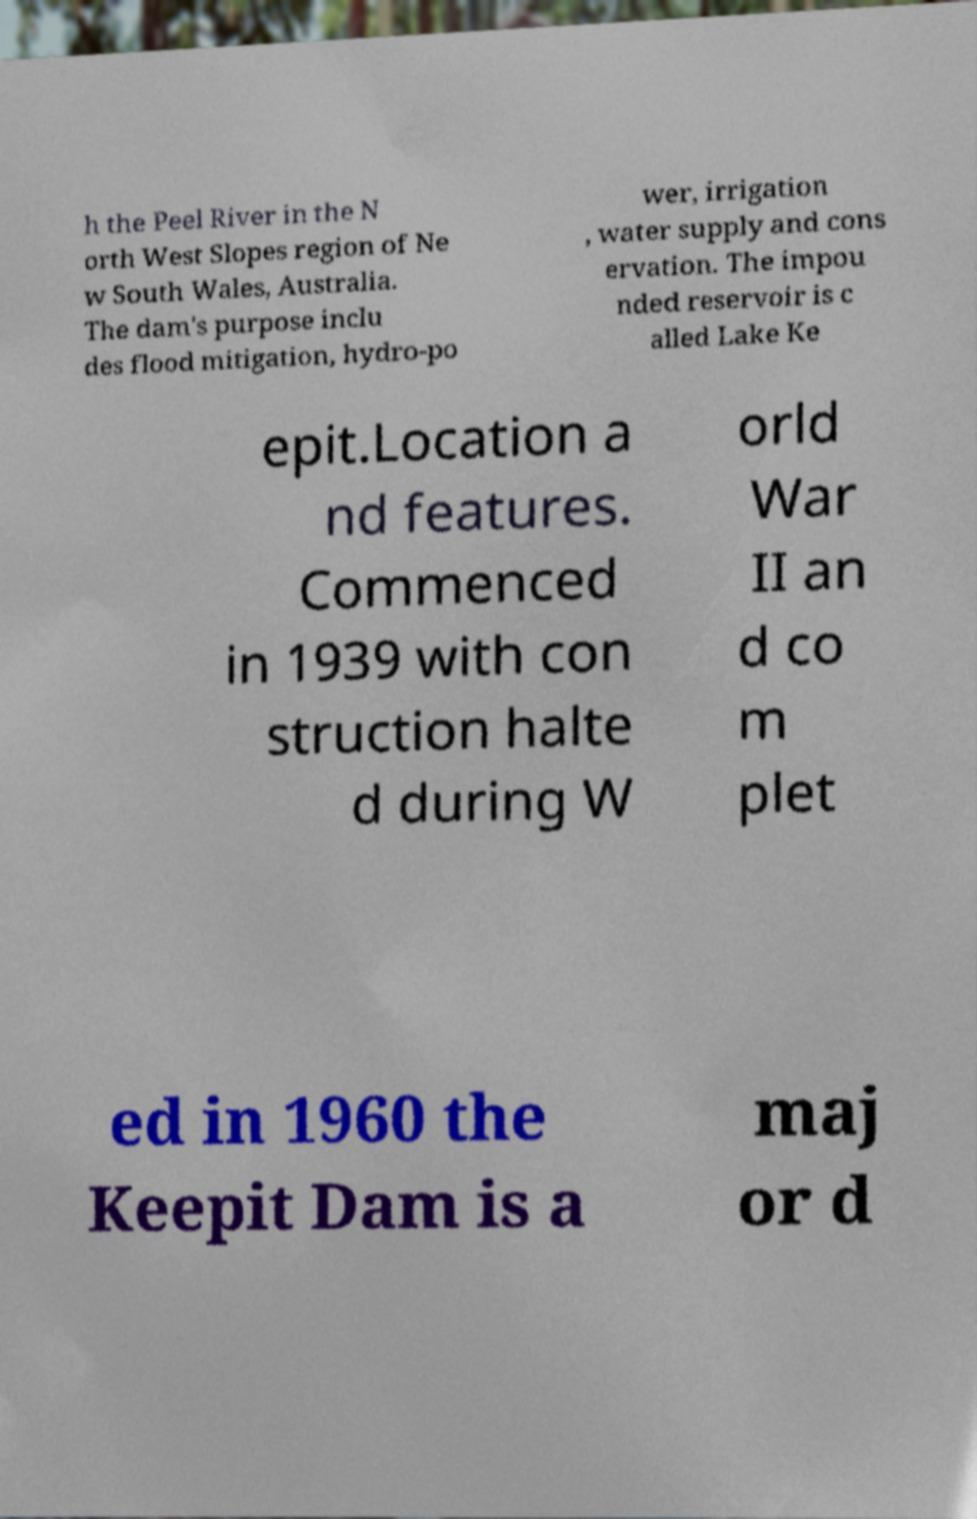There's text embedded in this image that I need extracted. Can you transcribe it verbatim? h the Peel River in the N orth West Slopes region of Ne w South Wales, Australia. The dam's purpose inclu des flood mitigation, hydro-po wer, irrigation , water supply and cons ervation. The impou nded reservoir is c alled Lake Ke epit.Location a nd features. Commenced in 1939 with con struction halte d during W orld War II an d co m plet ed in 1960 the Keepit Dam is a maj or d 